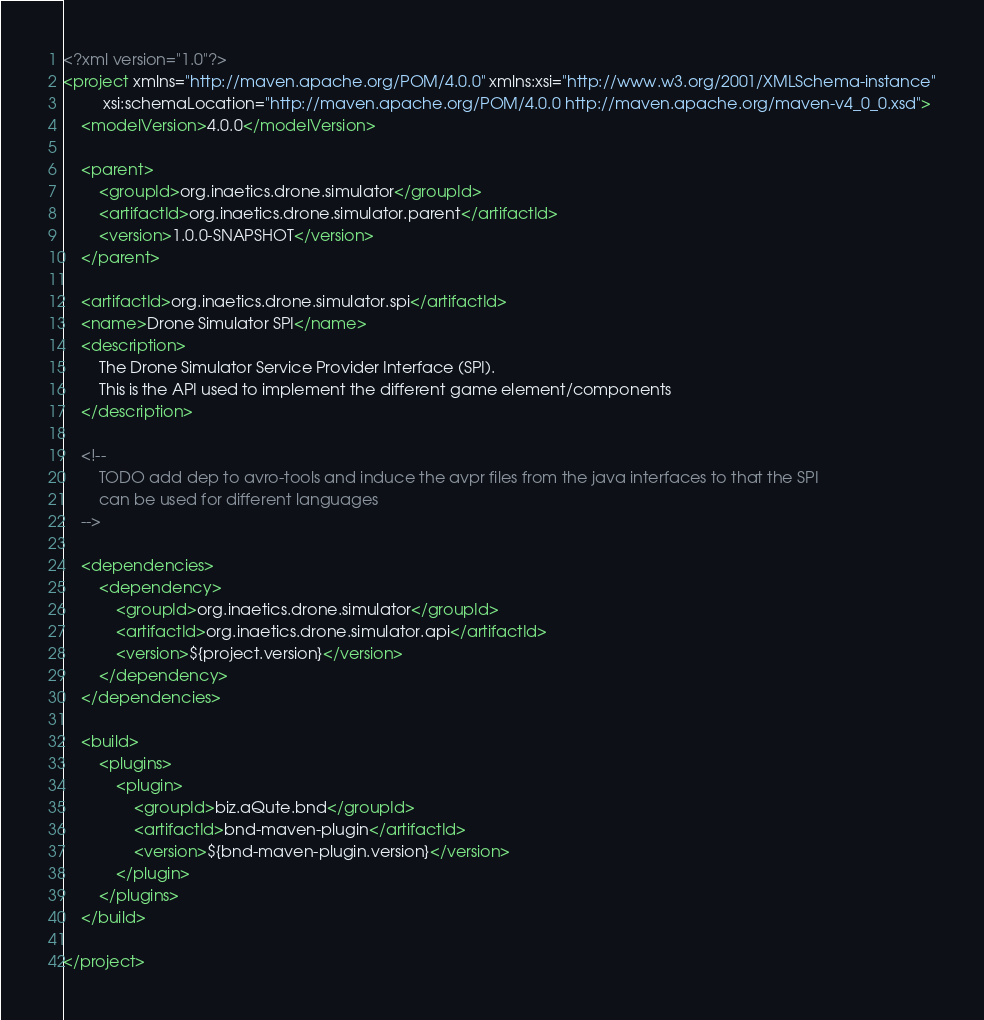Convert code to text. <code><loc_0><loc_0><loc_500><loc_500><_XML_><?xml version="1.0"?>
<project xmlns="http://maven.apache.org/POM/4.0.0" xmlns:xsi="http://www.w3.org/2001/XMLSchema-instance"
         xsi:schemaLocation="http://maven.apache.org/POM/4.0.0 http://maven.apache.org/maven-v4_0_0.xsd">
    <modelVersion>4.0.0</modelVersion>

    <parent>
        <groupId>org.inaetics.drone.simulator</groupId>
        <artifactId>org.inaetics.drone.simulator.parent</artifactId>
        <version>1.0.0-SNAPSHOT</version>
    </parent>

    <artifactId>org.inaetics.drone.simulator.spi</artifactId>
    <name>Drone Simulator SPI</name>
    <description>
        The Drone Simulator Service Provider Interface (SPI).
        This is the API used to implement the different game element/components
    </description>

    <!--
        TODO add dep to avro-tools and induce the avpr files from the java interfaces to that the SPI
        can be used for different languages
    -->

    <dependencies>
        <dependency>
            <groupId>org.inaetics.drone.simulator</groupId>
            <artifactId>org.inaetics.drone.simulator.api</artifactId>
            <version>${project.version}</version>
        </dependency>
    </dependencies>

    <build>
        <plugins>
            <plugin>
                <groupId>biz.aQute.bnd</groupId>
                <artifactId>bnd-maven-plugin</artifactId>
                <version>${bnd-maven-plugin.version}</version>
            </plugin>
        </plugins>
    </build>

</project>
</code> 